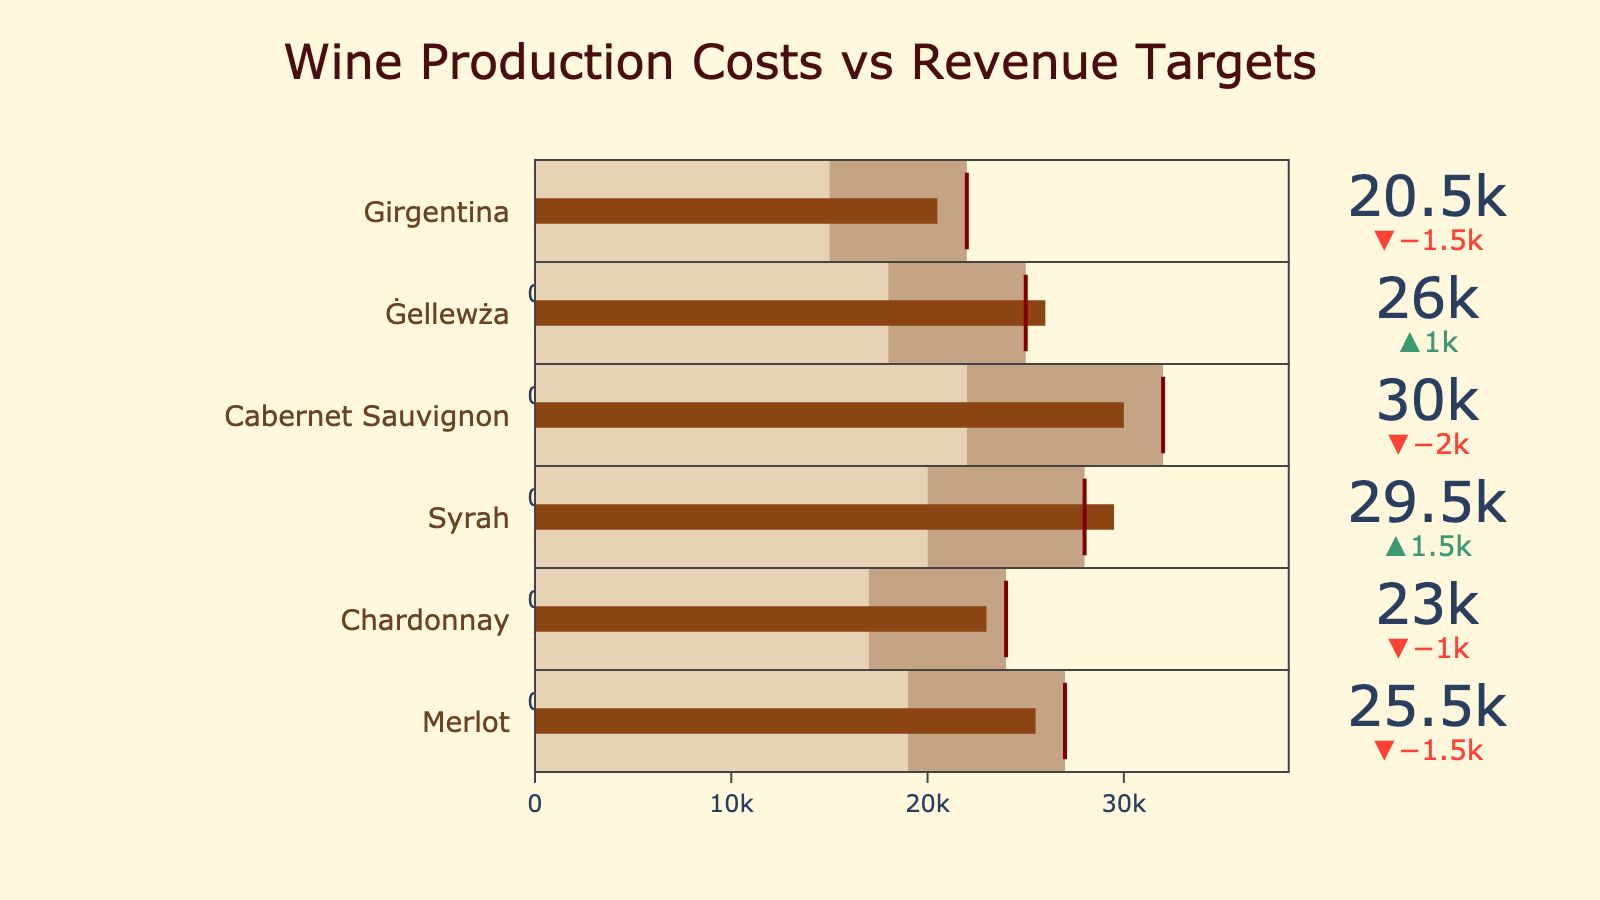What is the title of the chart? The title is displayed prominently at the top of the chart. By reading the title, we understand what the data represents.
Answer: Wine Production Costs vs Revenue Targets Which wine type has the highest production cost? By looking at the bullet charts, we compare the leftmost gray segments of each wine type. The longest leftmost segment corresponds to Cabernet Sauvignon.
Answer: Cabernet Sauvignon Which wine type exceeded its revenue target? By checking the value indicators on the chart, we observe that Ġellewża and Syrah both have actual revenues exceeding their respective targets, indicated by green deltas.
Answer: Ġellewża and Syrah How much did Chardonnay fall short of its revenue target? The delta indicator next to Chardonnay shows the difference between the actual revenue and the target revenue. Chardonnay's actual revenue is 23000, whereas its target is 24000.
Answer: 1000 What's the difference in production costs between Merlot and Girgentina? We compare the leftmost segments: Merlot's cost is 19000 and Girgentina's cost is 15000. Calculate the difference: 19000 - 15000.
Answer: 4000 Which wine type has the closest actual revenue to its production cost? Look at the values for actual revenue and production cost for each wine type, then find the smallest difference. Girgentina's production cost is 15000 and its actual revenue is 20500, a difference of 5500. This is the smallest gap visible.
Answer: Girgentina What is the total production cost for all wine types? Sum the production costs: 15000 (Girgentina) + 18000 (Ġellewża) + 22000 (Cabernet Sauvignon) + 20000 (Syrah) + 17000 (Chardonnay) + 19000 (Merlot). The total is 111000.
Answer: 111000 Which wine type's actual revenue is closest to its revenue target? Compare the actual revenues against the targets. The wine type with the smallest delta discrepancy is Girgentina (20500 vs 22000, a difference of 1500).
Answer: Girgentina What is the revenue target for Syrah? Refer to the marked threshold line in the bullet chart for Syrah, which shows the revenue target value.
Answer: 28000 How does the production cost of Girgentina compare with its revenue target? Girgentina's production cost is 15000 and its revenue target is 22000. The production cost is less than the revenue target by 7000.
Answer: Less by 7000 